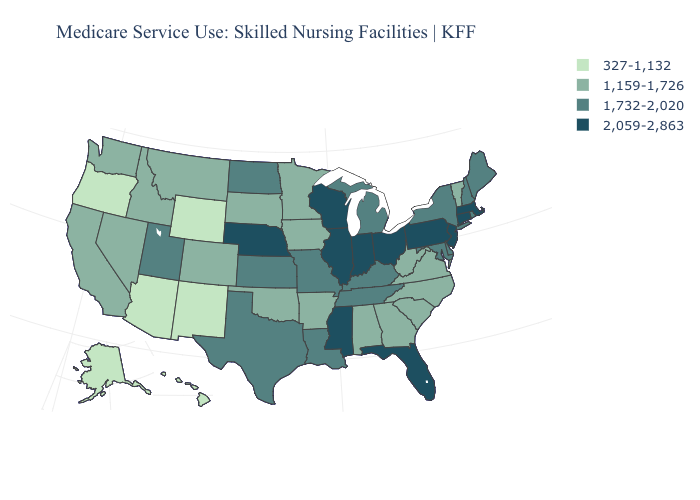Name the states that have a value in the range 327-1,132?
Answer briefly. Alaska, Arizona, Hawaii, New Mexico, Oregon, Wyoming. Name the states that have a value in the range 2,059-2,863?
Answer briefly. Connecticut, Florida, Illinois, Indiana, Massachusetts, Mississippi, Nebraska, New Jersey, Ohio, Pennsylvania, Wisconsin. Does Nevada have the same value as Colorado?
Be succinct. Yes. Name the states that have a value in the range 2,059-2,863?
Quick response, please. Connecticut, Florida, Illinois, Indiana, Massachusetts, Mississippi, Nebraska, New Jersey, Ohio, Pennsylvania, Wisconsin. Which states have the lowest value in the West?
Give a very brief answer. Alaska, Arizona, Hawaii, New Mexico, Oregon, Wyoming. Name the states that have a value in the range 1,159-1,726?
Short answer required. Alabama, Arkansas, California, Colorado, Georgia, Idaho, Iowa, Minnesota, Montana, Nevada, North Carolina, Oklahoma, South Carolina, South Dakota, Vermont, Virginia, Washington, West Virginia. What is the value of Nebraska?
Be succinct. 2,059-2,863. What is the value of Vermont?
Give a very brief answer. 1,159-1,726. Name the states that have a value in the range 2,059-2,863?
Be succinct. Connecticut, Florida, Illinois, Indiana, Massachusetts, Mississippi, Nebraska, New Jersey, Ohio, Pennsylvania, Wisconsin. How many symbols are there in the legend?
Write a very short answer. 4. Does Montana have the highest value in the USA?
Short answer required. No. What is the value of Minnesota?
Write a very short answer. 1,159-1,726. Does the first symbol in the legend represent the smallest category?
Quick response, please. Yes. Does New York have a higher value than Idaho?
Answer briefly. Yes. What is the value of Tennessee?
Be succinct. 1,732-2,020. 